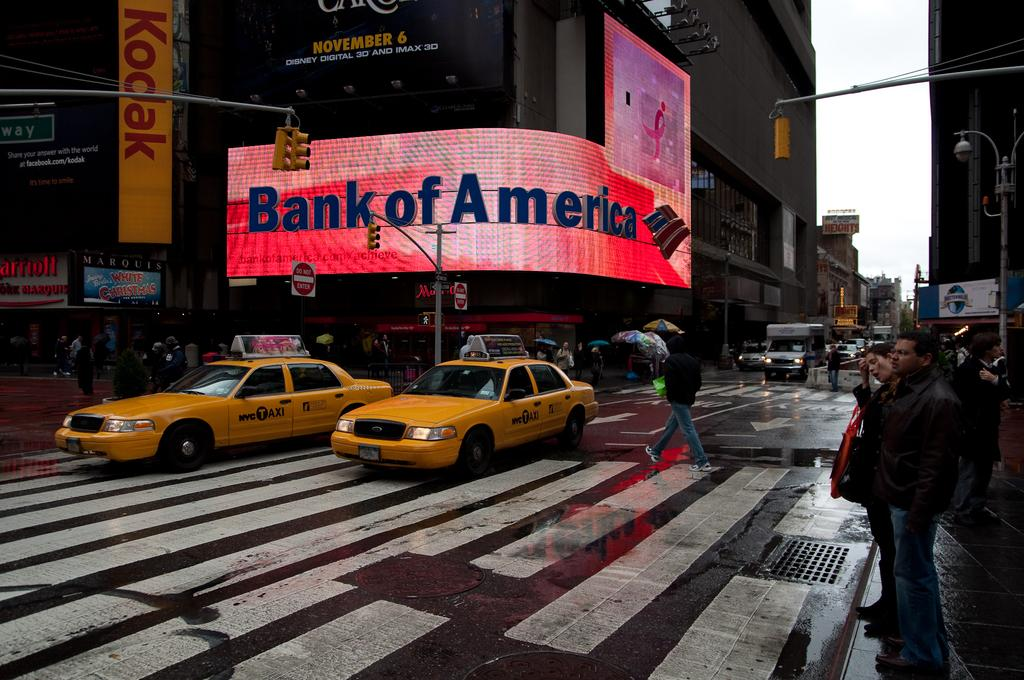<image>
Present a compact description of the photo's key features. A curved, lighted, signboard in red with Bank of America in blue on a buy street. 